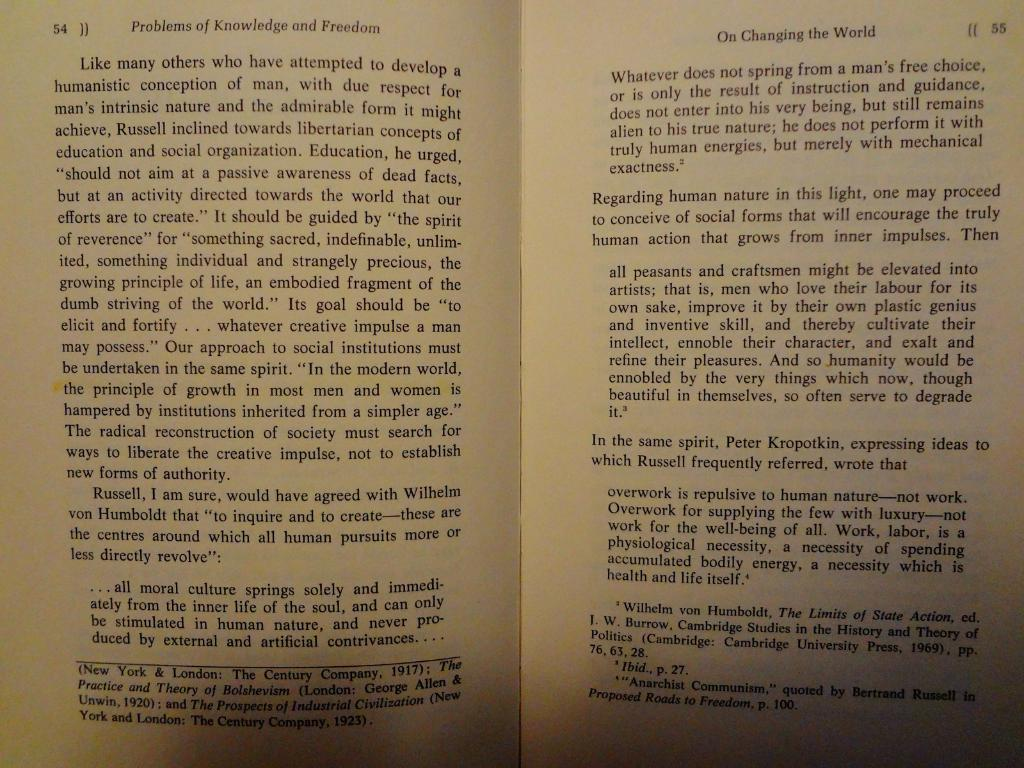<image>
Write a terse but informative summary of the picture. A book is opened to page 54 and 55. 